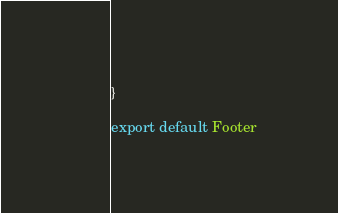Convert code to text. <code><loc_0><loc_0><loc_500><loc_500><_JavaScript_>}

export default Footer
</code> 